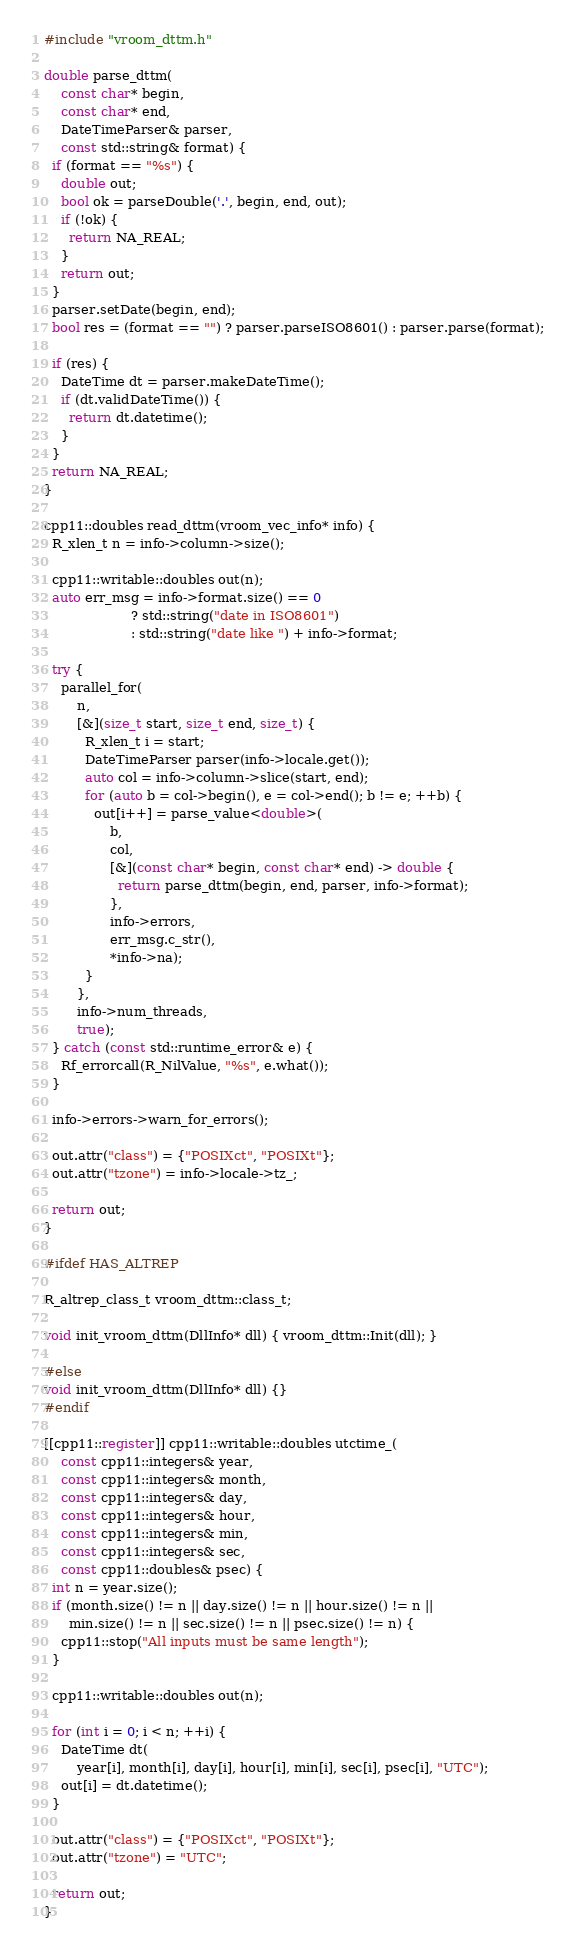<code> <loc_0><loc_0><loc_500><loc_500><_C++_>#include "vroom_dttm.h"

double parse_dttm(
    const char* begin,
    const char* end,
    DateTimeParser& parser,
    const std::string& format) {
  if (format == "%s") {
    double out;
    bool ok = parseDouble('.', begin, end, out);
    if (!ok) {
      return NA_REAL;
    }
    return out;
  }
  parser.setDate(begin, end);
  bool res = (format == "") ? parser.parseISO8601() : parser.parse(format);

  if (res) {
    DateTime dt = parser.makeDateTime();
    if (dt.validDateTime()) {
      return dt.datetime();
    }
  }
  return NA_REAL;
}

cpp11::doubles read_dttm(vroom_vec_info* info) {
  R_xlen_t n = info->column->size();

  cpp11::writable::doubles out(n);
  auto err_msg = info->format.size() == 0
                     ? std::string("date in ISO8601")
                     : std::string("date like ") + info->format;

  try {
    parallel_for(
        n,
        [&](size_t start, size_t end, size_t) {
          R_xlen_t i = start;
          DateTimeParser parser(info->locale.get());
          auto col = info->column->slice(start, end);
          for (auto b = col->begin(), e = col->end(); b != e; ++b) {
            out[i++] = parse_value<double>(
                b,
                col,
                [&](const char* begin, const char* end) -> double {
                  return parse_dttm(begin, end, parser, info->format);
                },
                info->errors,
                err_msg.c_str(),
                *info->na);
          }
        },
        info->num_threads,
        true);
  } catch (const std::runtime_error& e) {
    Rf_errorcall(R_NilValue, "%s", e.what());
  }

  info->errors->warn_for_errors();

  out.attr("class") = {"POSIXct", "POSIXt"};
  out.attr("tzone") = info->locale->tz_;

  return out;
}

#ifdef HAS_ALTREP

R_altrep_class_t vroom_dttm::class_t;

void init_vroom_dttm(DllInfo* dll) { vroom_dttm::Init(dll); }

#else
void init_vroom_dttm(DllInfo* dll) {}
#endif

[[cpp11::register]] cpp11::writable::doubles utctime_(
    const cpp11::integers& year,
    const cpp11::integers& month,
    const cpp11::integers& day,
    const cpp11::integers& hour,
    const cpp11::integers& min,
    const cpp11::integers& sec,
    const cpp11::doubles& psec) {
  int n = year.size();
  if (month.size() != n || day.size() != n || hour.size() != n ||
      min.size() != n || sec.size() != n || psec.size() != n) {
    cpp11::stop("All inputs must be same length");
  }

  cpp11::writable::doubles out(n);

  for (int i = 0; i < n; ++i) {
    DateTime dt(
        year[i], month[i], day[i], hour[i], min[i], sec[i], psec[i], "UTC");
    out[i] = dt.datetime();
  }

  out.attr("class") = {"POSIXct", "POSIXt"};
  out.attr("tzone") = "UTC";

  return out;
}
</code> 